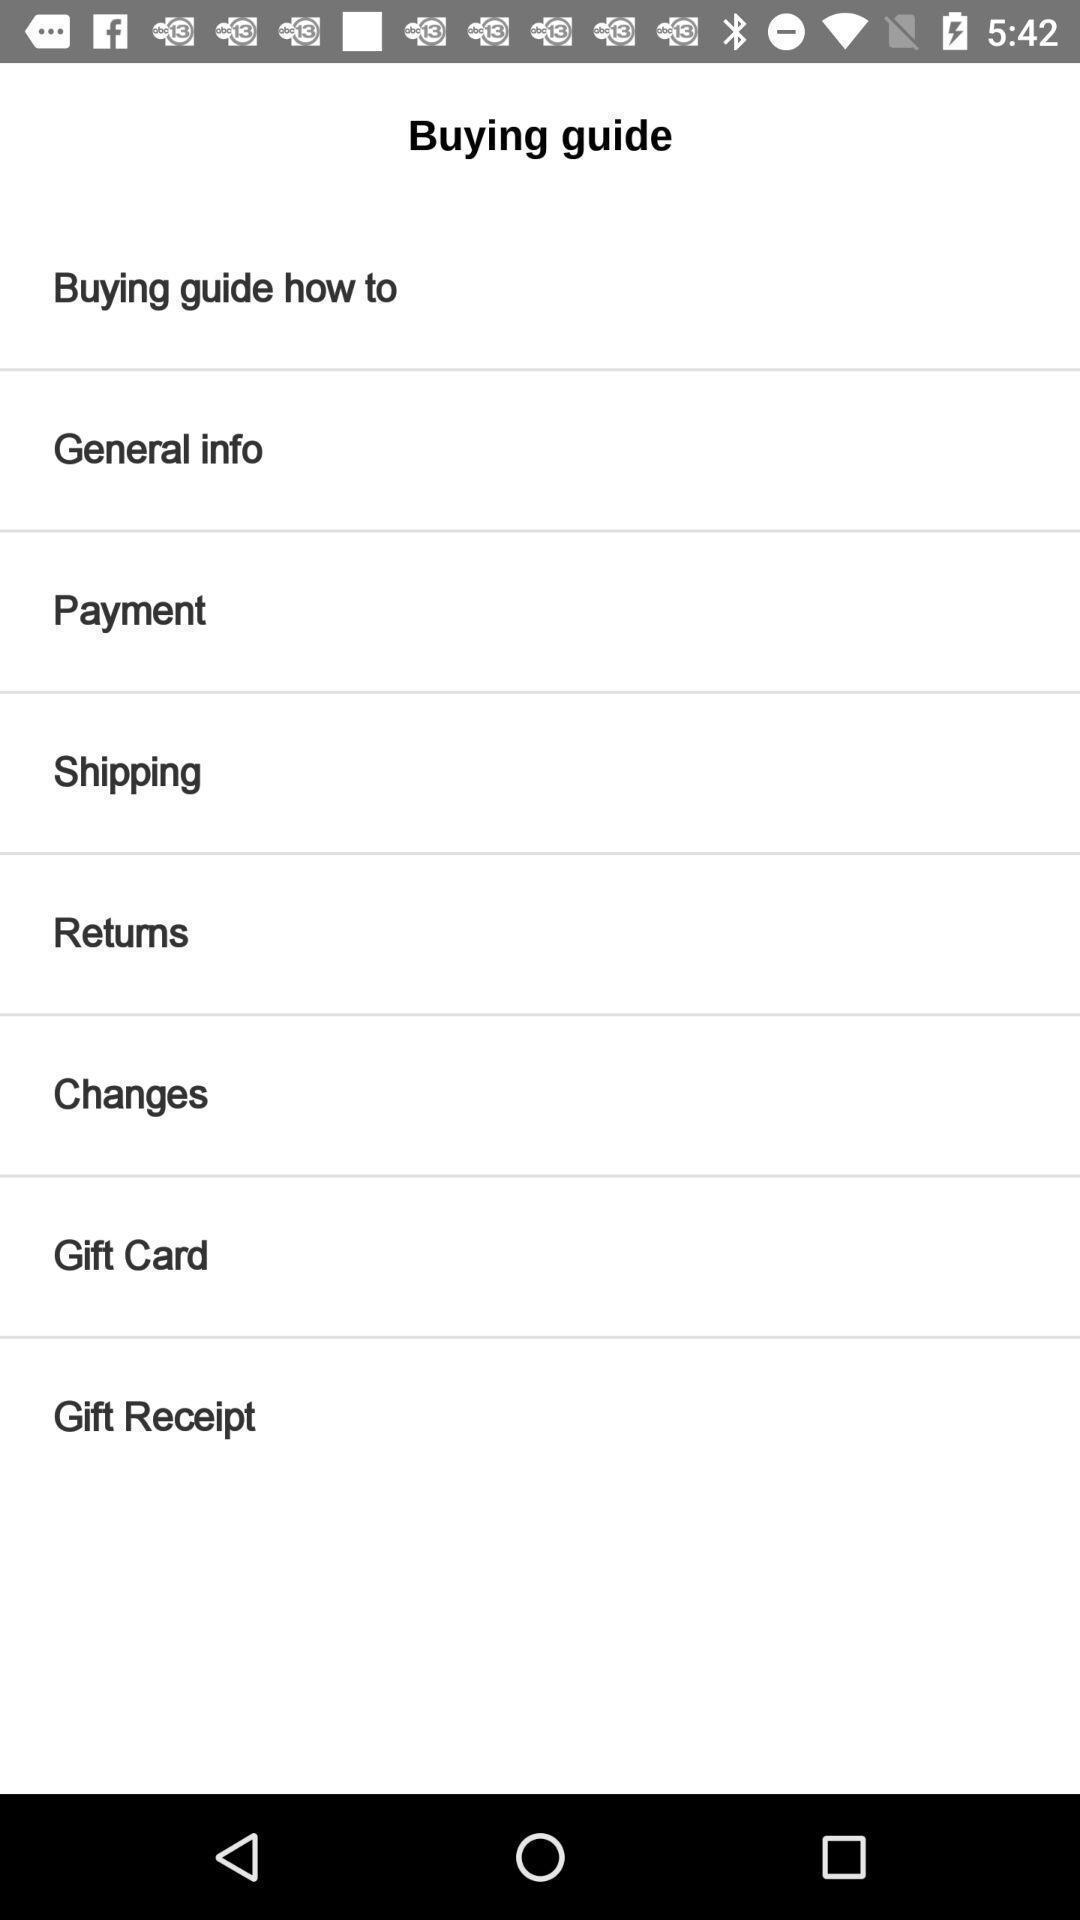Explain the elements present in this screenshot. Page displays different categories in a shopping app. 